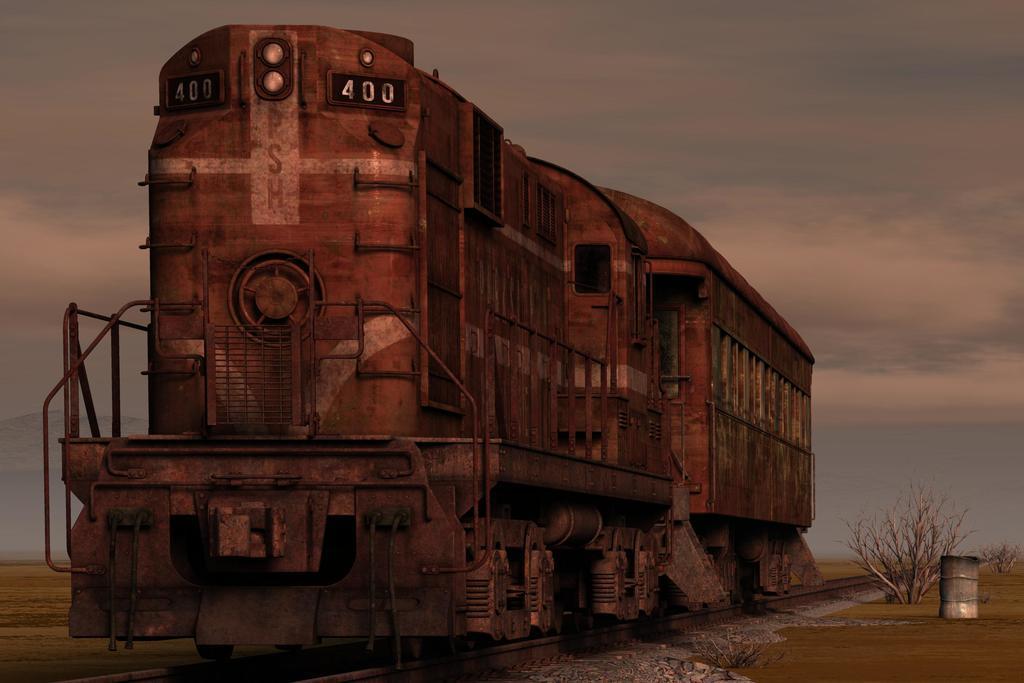Can you describe this image briefly? In this image we can see a train on the tracks, there are some plants, stones and an object, in the background we can see the sky. 